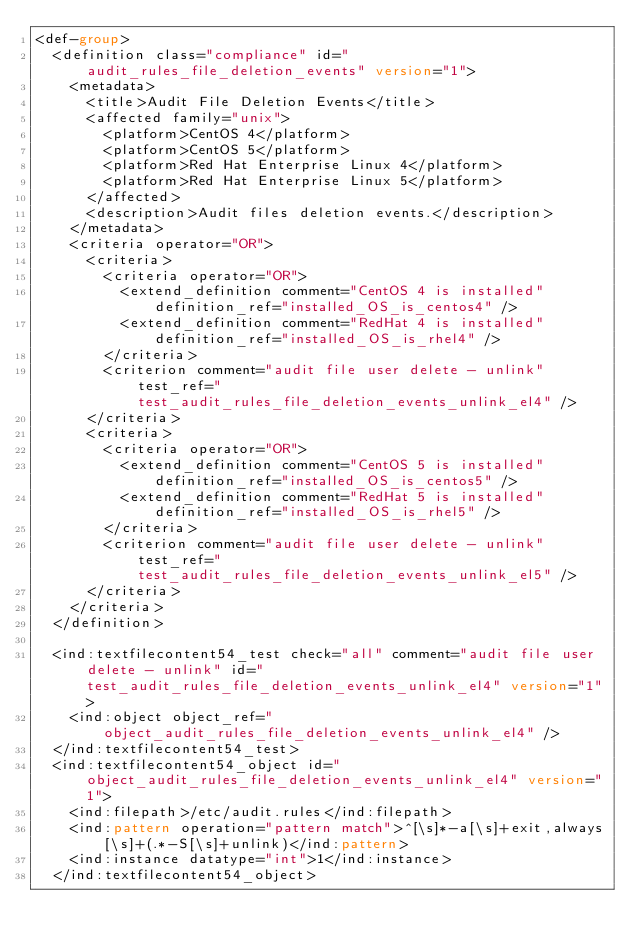<code> <loc_0><loc_0><loc_500><loc_500><_XML_><def-group>
  <definition class="compliance" id="audit_rules_file_deletion_events" version="1">
    <metadata>
      <title>Audit File Deletion Events</title>
      <affected family="unix">
        <platform>CentOS 4</platform>
		<platform>CentOS 5</platform>
		<platform>Red Hat Enterprise Linux 4</platform>
		<platform>Red Hat Enterprise Linux 5</platform>
      </affected>
      <description>Audit files deletion events.</description>
    </metadata>
    <criteria operator="OR">
      <criteria>
        <criteria operator="OR">
	      <extend_definition comment="CentOS 4 is installed" definition_ref="installed_OS_is_centos4" />
	      <extend_definition comment="RedHat 4 is installed" definition_ref="installed_OS_is_rhel4" />
        </criteria>
        <criterion comment="audit file user delete - unlink" test_ref="test_audit_rules_file_deletion_events_unlink_el4" />
      </criteria>
      <criteria>
        <criteria operator="OR">
	      <extend_definition comment="CentOS 5 is installed" definition_ref="installed_OS_is_centos5" />
	      <extend_definition comment="RedHat 5 is installed" definition_ref="installed_OS_is_rhel5" />
        </criteria>
        <criterion comment="audit file user delete - unlink" test_ref="test_audit_rules_file_deletion_events_unlink_el5" />
      </criteria>
    </criteria>
  </definition>

  <ind:textfilecontent54_test check="all" comment="audit file user delete - unlink" id="test_audit_rules_file_deletion_events_unlink_el4" version="1">
    <ind:object object_ref="object_audit_rules_file_deletion_events_unlink_el4" />
  </ind:textfilecontent54_test>
  <ind:textfilecontent54_object id="object_audit_rules_file_deletion_events_unlink_el4" version="1">
    <ind:filepath>/etc/audit.rules</ind:filepath>
    <ind:pattern operation="pattern match">^[\s]*-a[\s]+exit,always[\s]+(.*-S[\s]+unlink)</ind:pattern>
    <ind:instance datatype="int">1</ind:instance>
  </ind:textfilecontent54_object>
</code> 